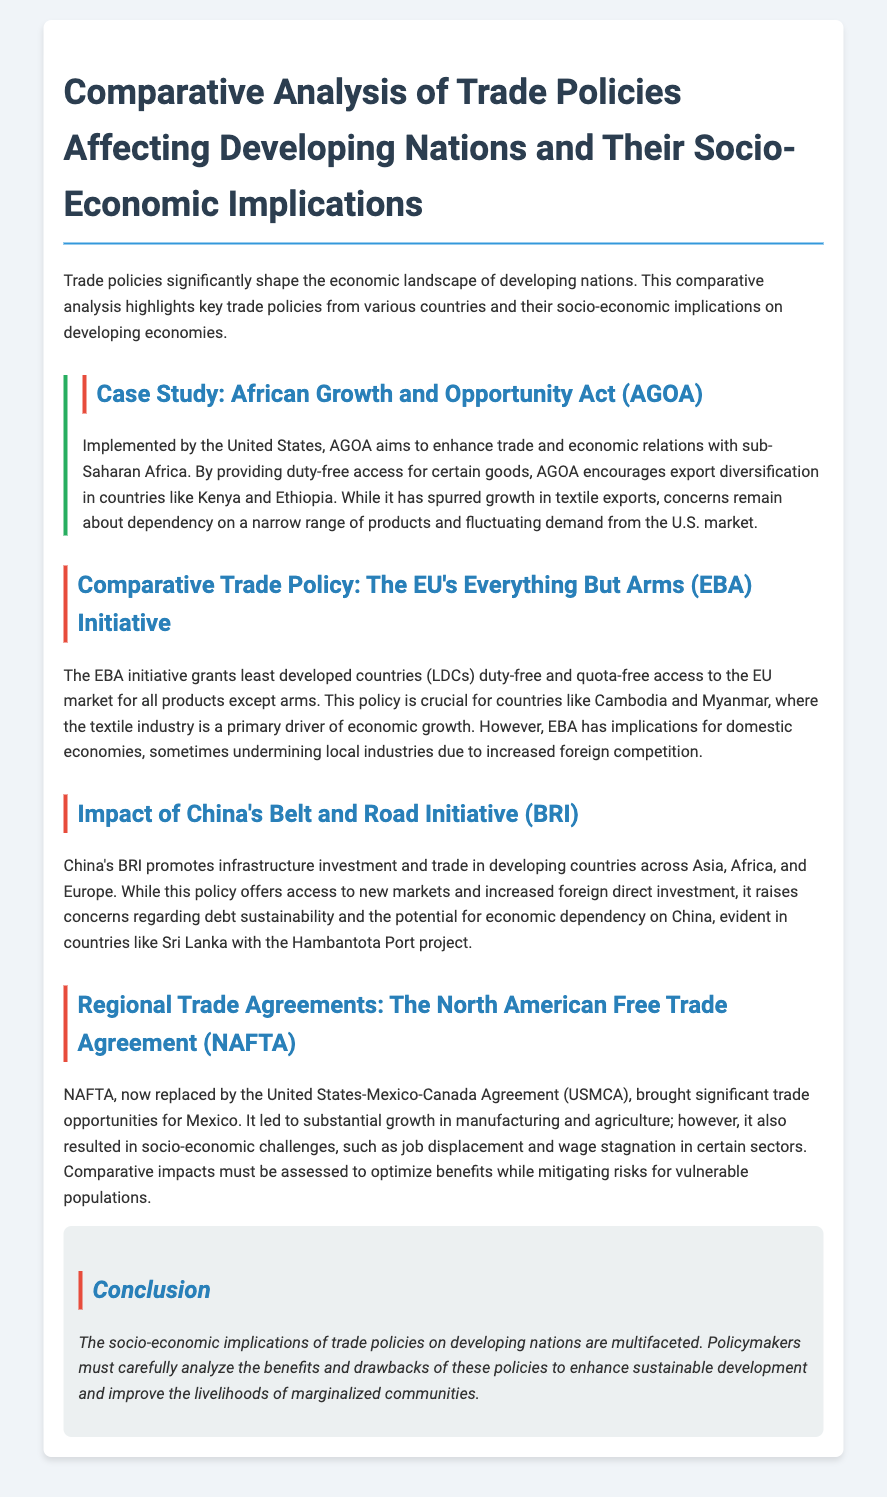What is the intention behind the AGOA? AGOA aims to enhance trade and economic relations with sub-Saharan Africa.
Answer: Enhance trade and economic relations What type of access does the EU's EBA initiative provide? The EBA initiative grants duty-free and quota-free access to the EU market for all products except arms.
Answer: Duty-free and quota-free access Which country is specifically mentioned in the document with the Belt and Road Initiative? The example of Sri Lanka is given in relation to debt sustainability concerns with the BRI.
Answer: Sri Lanka What did NAFTA bring significant trade opportunities for? NAFTA brought significant trade opportunities for Mexico.
Answer: Mexico What industry is a primary driver of economic growth in Cambodia and Myanmar? The textile industry is mentioned as a primary driver of economic growth.
Answer: Textile industry What is a key concern regarding AGOA's impact on certain goods? There are concerns about dependency on a narrow range of products and fluctuating demand.
Answer: Dependency and fluctuating demand What does the concluding paragraph emphasize for policymakers? The conclusion emphasizes analyzing the benefits and drawbacks of trade policies to enhance sustainable development.
Answer: Analyze benefits and drawbacks How did NAFTA impact certain sectors according to the document? The impact of NAFTA is associated with job displacement and wage stagnation in certain sectors.
Answer: Job displacement and wage stagnation 